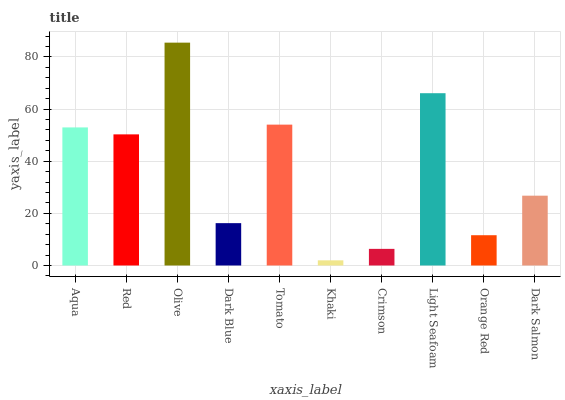Is Khaki the minimum?
Answer yes or no. Yes. Is Olive the maximum?
Answer yes or no. Yes. Is Red the minimum?
Answer yes or no. No. Is Red the maximum?
Answer yes or no. No. Is Aqua greater than Red?
Answer yes or no. Yes. Is Red less than Aqua?
Answer yes or no. Yes. Is Red greater than Aqua?
Answer yes or no. No. Is Aqua less than Red?
Answer yes or no. No. Is Red the high median?
Answer yes or no. Yes. Is Dark Salmon the low median?
Answer yes or no. Yes. Is Dark Salmon the high median?
Answer yes or no. No. Is Olive the low median?
Answer yes or no. No. 